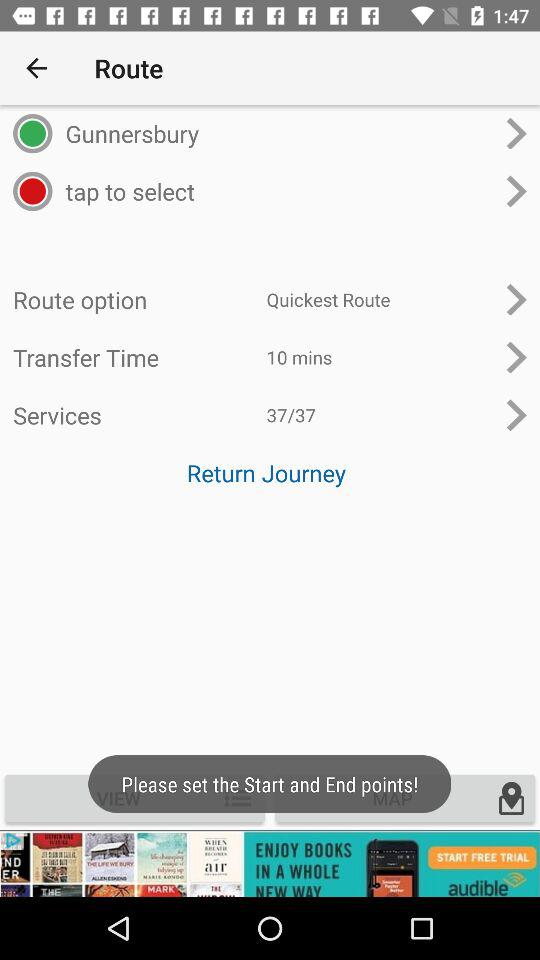What two options are given in the route? The given options are "Gunnersbury" and "tap to select". 